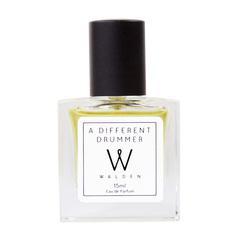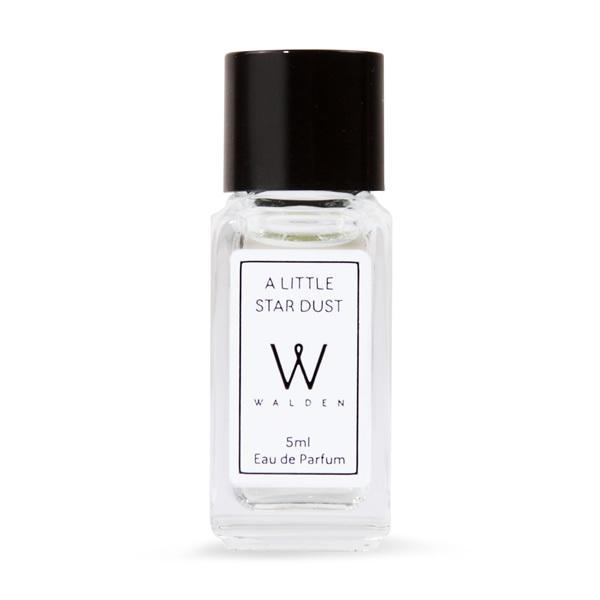The first image is the image on the left, the second image is the image on the right. Examine the images to the left and right. Is the description "A pink flower is on the left of an image containing a square bottled fragrance and its upright box." accurate? Answer yes or no. No. The first image is the image on the left, the second image is the image on the right. For the images displayed, is the sentence "In one image, a square shaped spray bottle of cologne has its cap off and positioned to the side of the bottle, while a second image shows a similar square bottle with the cap on." factually correct? Answer yes or no. No. 